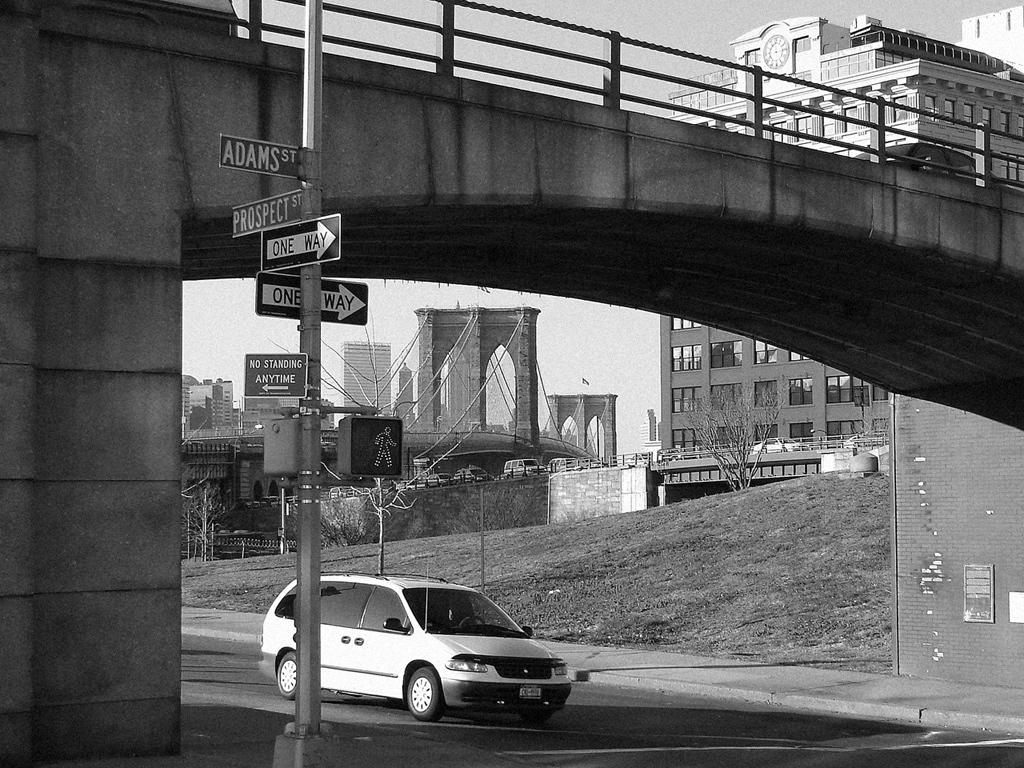<image>
Relay a brief, clear account of the picture shown. A Dodge Minivan drives under a bridge on the road. 